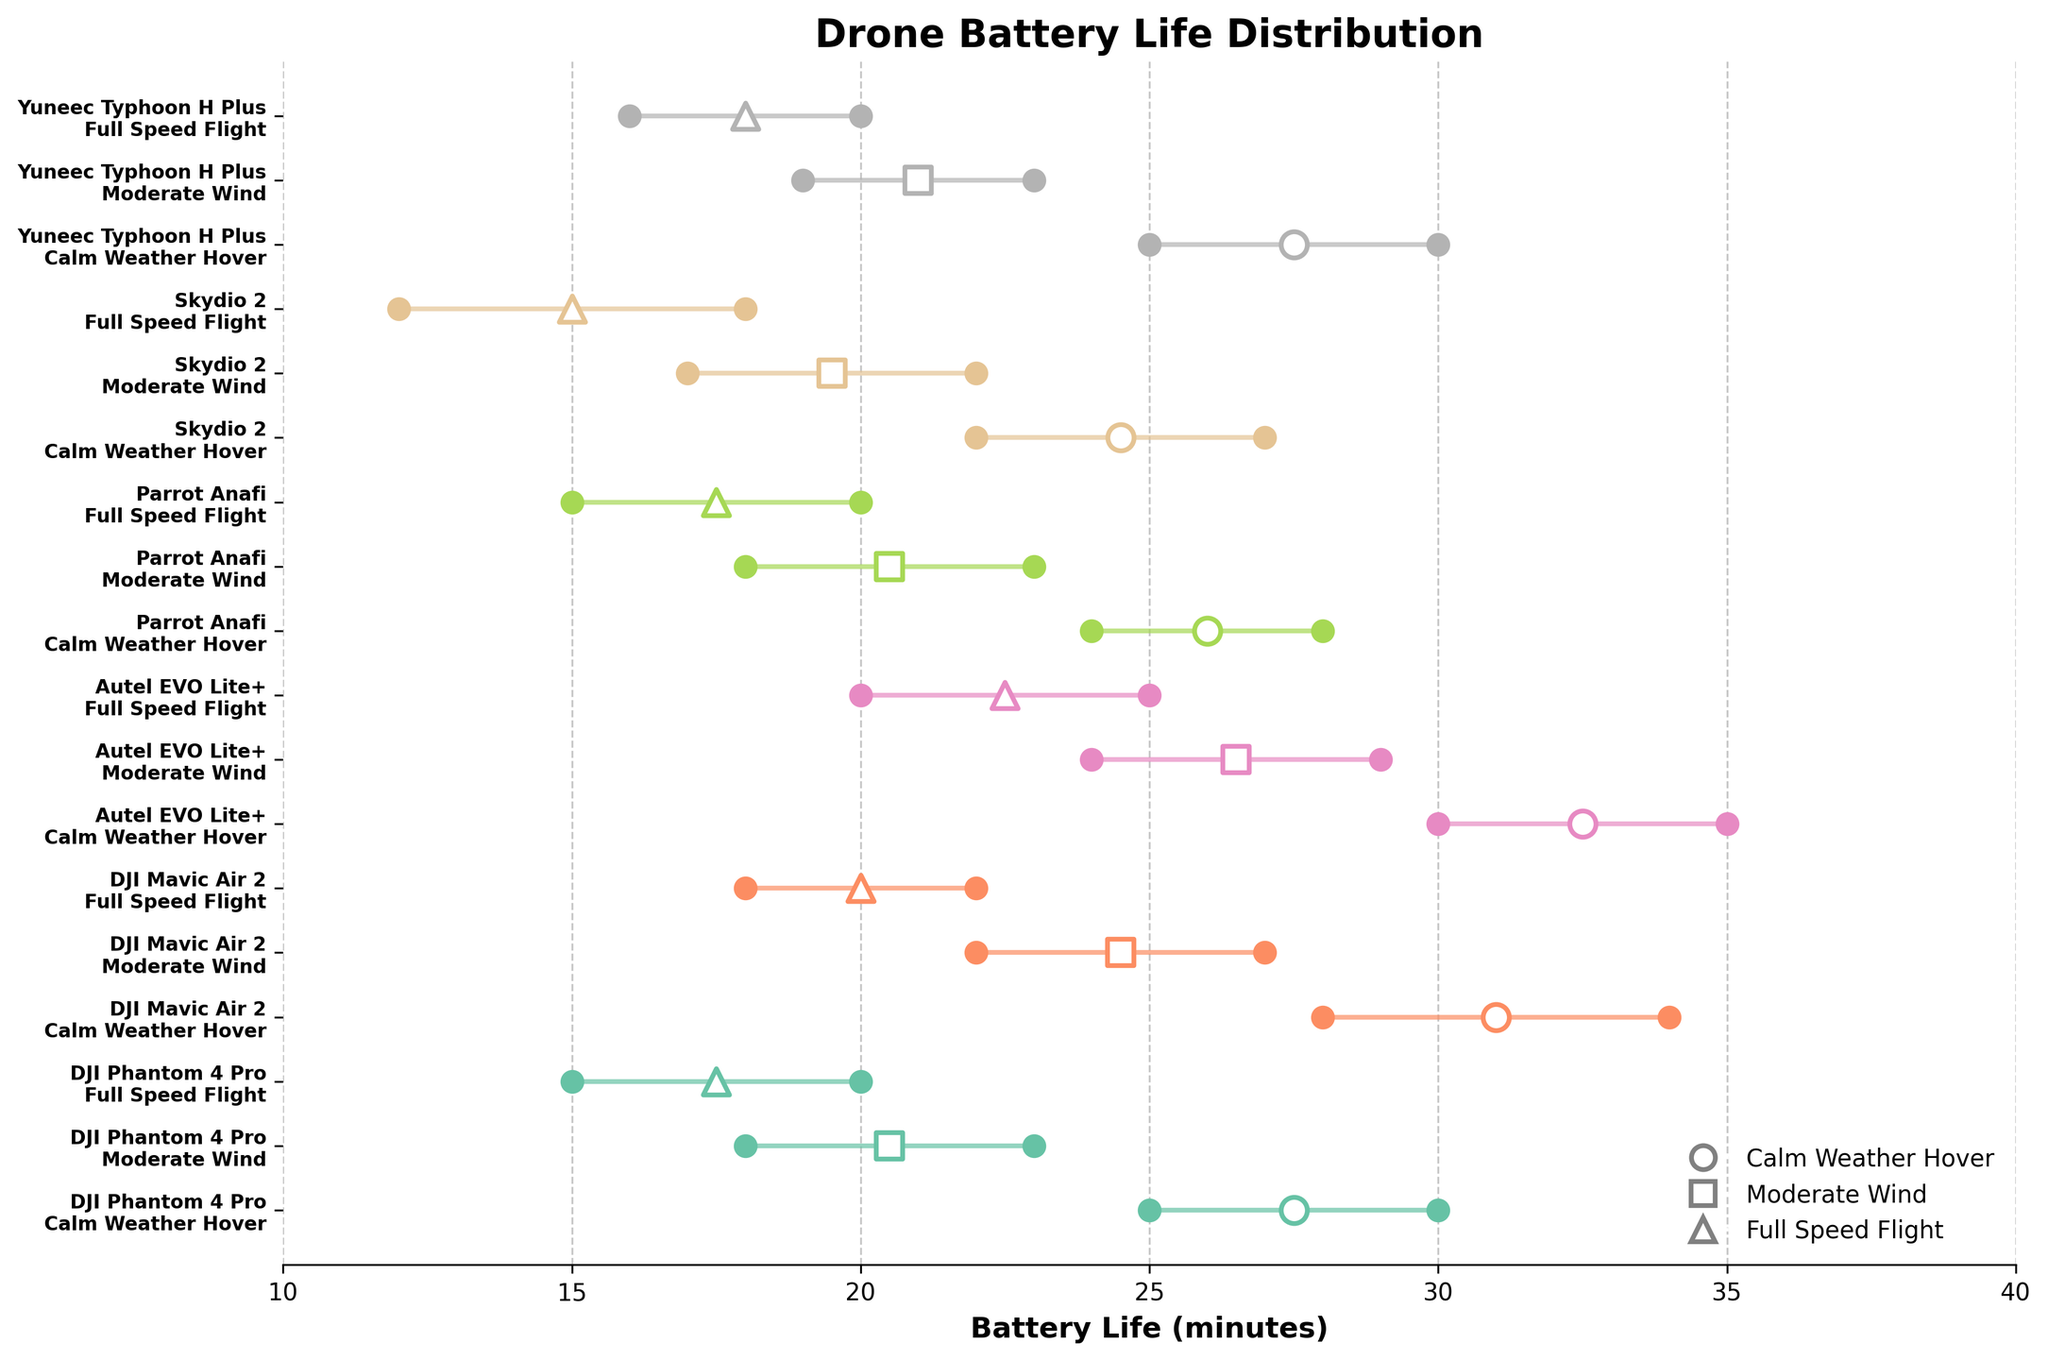How many drone models are displayed in the plot? By counting the unique drone model labels on the y-axis, you can determine the total number of drone models.
Answer: 5 What is the range of battery life for the DJI Phantom 4 Pro during moderate wind conditions? Locate the DJI Phantom 4 Pro row with 'Moderate Wind' on the y-axis and check the min and max battery life values on the x-axis.
Answer: 18-23 minutes Which operating condition generally provides the highest battery life for most drones? Compare the position and range of the battery life for the three operating conditions across multiple drone models. Calm Weather Hover typically has the highest battery life.
Answer: Calm Weather Hover Which drone model has the shortest maximum battery life during full speed flight? Find the rows corresponding to 'Full Speed Flight' and identify the model with the smallest maximum battery life value on the x-axis.
Answer: Skydio 2 What is the difference in maximum battery life between the Autel EVO Lite+ in calm weather hover and full speed flight? Locate the rows for Autel EVO Lite+ under respective conditions and subtract the maximum battery life of full speed flight from that of calm weather hover.
Answer: 10 minutes Which drone model shows the most significant variation in battery life between calm weather hover and full speed flight? Observe the range bars for each drone model under these conditions and identify the model with the widest gap between ranges.
Answer: Autel EVO Lite+ Is there a model where the minimum battery life during moderate wind exceeds the maximum battery life during full speed flight? Compare the min battery life values under 'Moderate Wind' conditions with the max battery life values under 'Full Speed Flight' for each model.
Answer: Yes, DJI Mavic Air 2 What is the median battery life range for Skydio 2 under all conditions? Identify the ranges for Skydio 2 across all conditions, order them, and find the middle value. Sorting: 12-18, 17-22, 22-27; Median is the middle range.
Answer: 17-22 minutes Which drone models have an equal range of battery life in calm weather hover? Compare the range bars for all the models under 'Calm Weather Hover' to identify any that span the same interval.
Answer: DJI Phantom 4 Pro and Yuneec Typhoon H Plus 